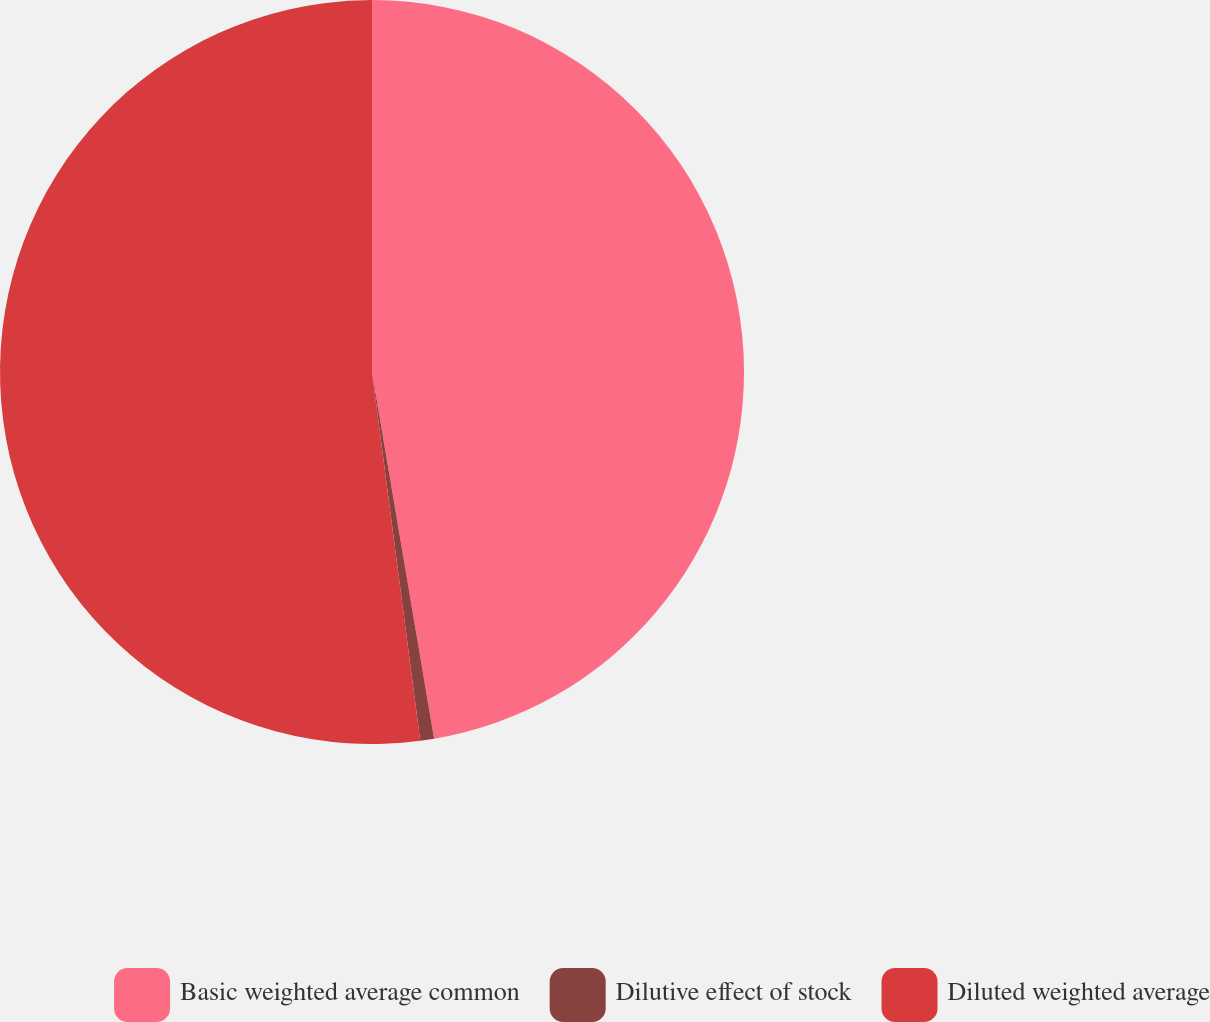Convert chart. <chart><loc_0><loc_0><loc_500><loc_500><pie_chart><fcel>Basic weighted average common<fcel>Dilutive effect of stock<fcel>Diluted weighted average<nl><fcel>47.33%<fcel>0.6%<fcel>52.07%<nl></chart> 